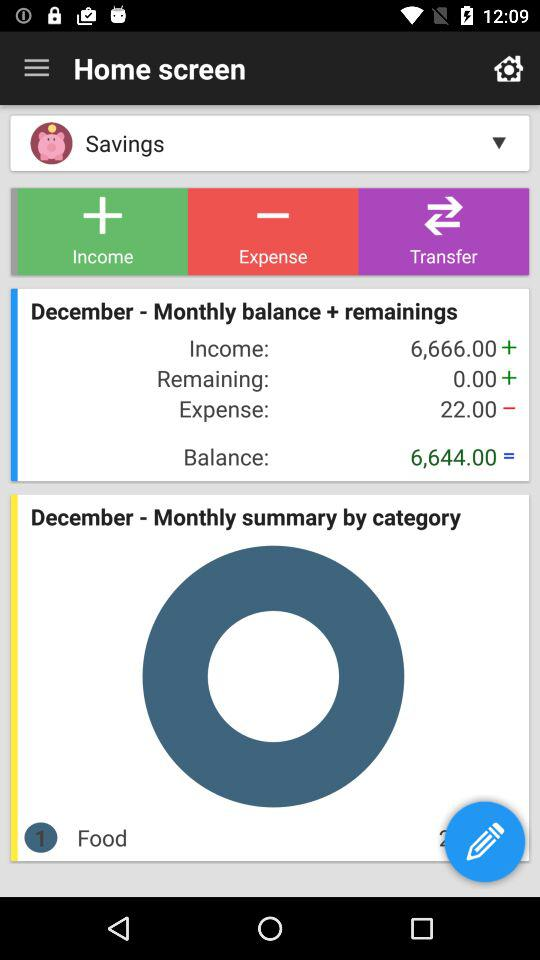How much is the remaining balance?
Answer the question using a single word or phrase. 6,644.00 